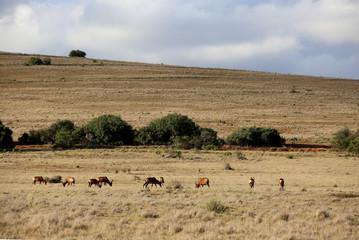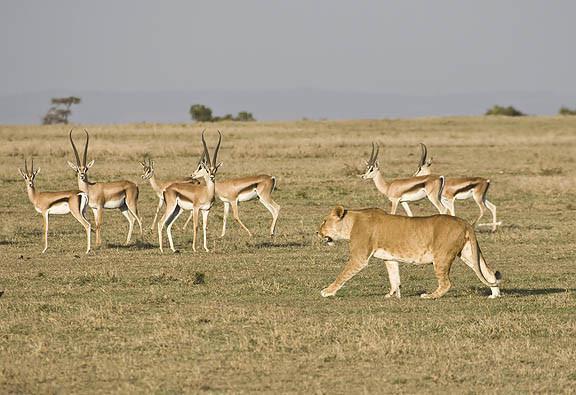The first image is the image on the left, the second image is the image on the right. For the images shown, is this caption "An image shows multiple similarly-posed gazelles with dark diagonal stripes across their bodies." true? Answer yes or no. Yes. 